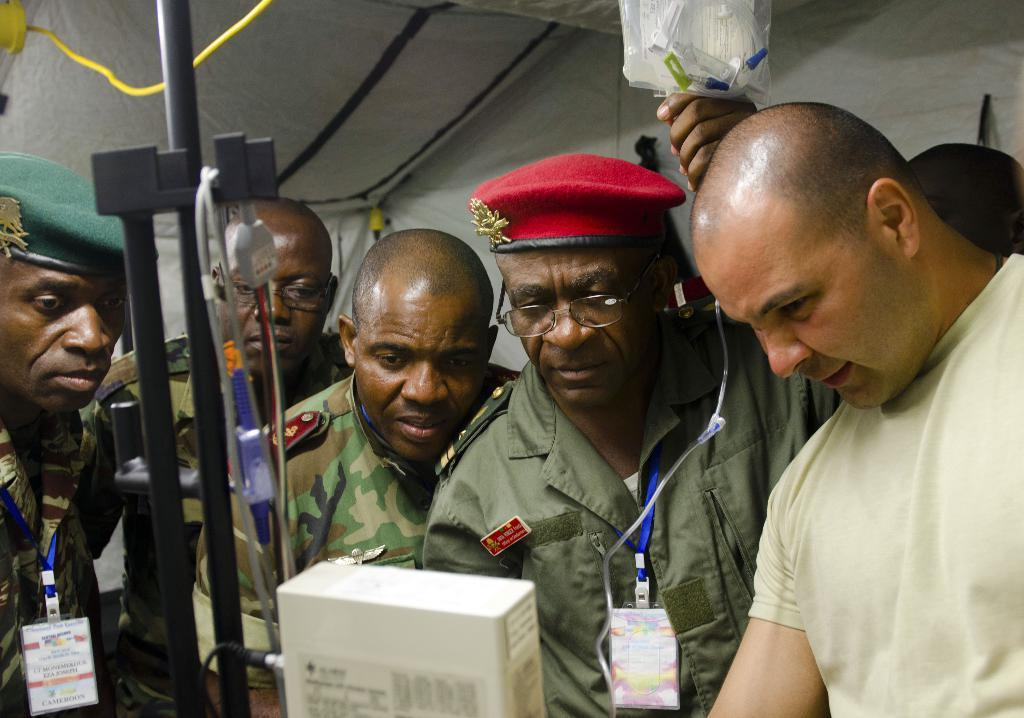How many people are in the image? There are persons standing in the image. What are the persons doing in the image? The persons are looking into something. What can be seen in the background of the image? There is a tent, electric cables, and machines in the background of the image. Reasoning: Let'g: Let's think step by step in order to produce the conversation. We start by identifying the main subjects in the image, which are the persons standing. Then, we describe what they are doing, which is looking into something. Finally, we expand the conversation to include the background of the image, mentioning the tent, electric cables, and machines. Absurd Question/Answer: What type of insect can be seen crawling on the patch in the image? There is no insect or patch present in the image. Is there a jail visible in the image? There is no jail present in the image. 